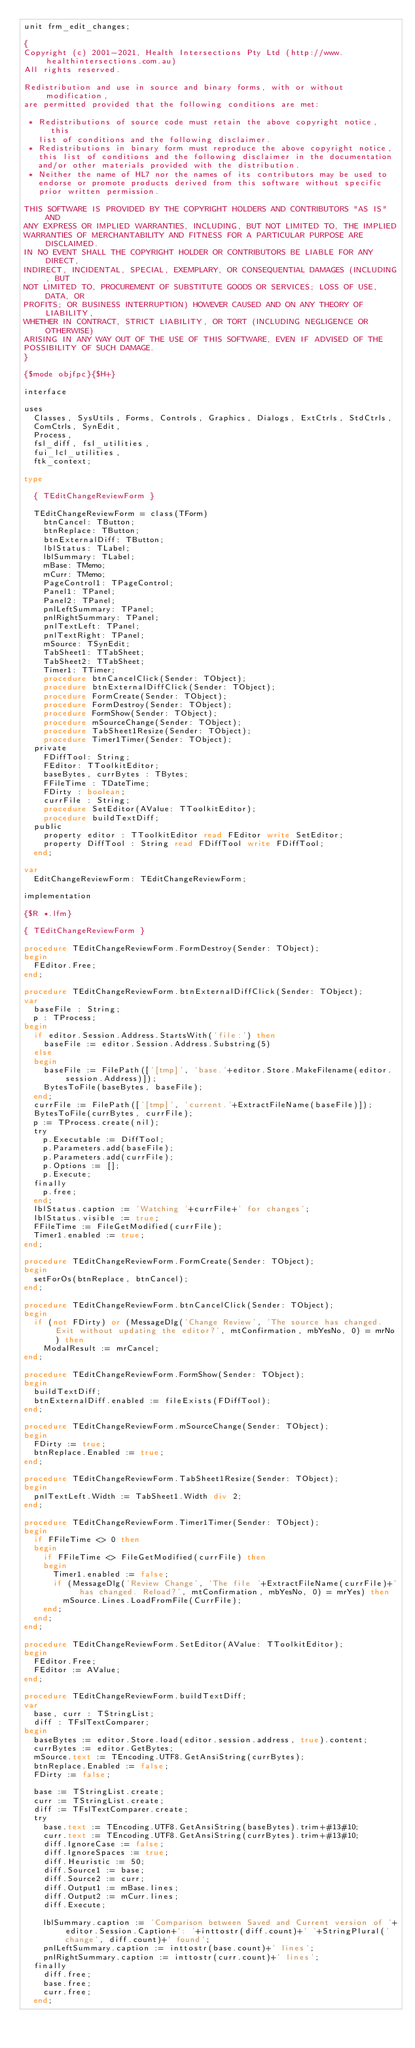Convert code to text. <code><loc_0><loc_0><loc_500><loc_500><_Pascal_>unit frm_edit_changes;

{
Copyright (c) 2001-2021, Health Intersections Pty Ltd (http://www.healthintersections.com.au)
All rights reserved.

Redistribution and use in source and binary forms, with or without modification,
are permitted provided that the following conditions are met:

 * Redistributions of source code must retain the above copyright notice, this
   list of conditions and the following disclaimer.
 * Redistributions in binary form must reproduce the above copyright notice,
   this list of conditions and the following disclaimer in the documentation
   and/or other materials provided with the distribution.
 * Neither the name of HL7 nor the names of its contributors may be used to
   endorse or promote products derived from this software without specific
   prior written permission.

THIS SOFTWARE IS PROVIDED BY THE COPYRIGHT HOLDERS AND CONTRIBUTORS "AS IS" AND
ANY EXPRESS OR IMPLIED WARRANTIES, INCLUDING, BUT NOT LIMITED TO, THE IMPLIED
WARRANTIES OF MERCHANTABILITY AND FITNESS FOR A PARTICULAR PURPOSE ARE DISCLAIMED.
IN NO EVENT SHALL THE COPYRIGHT HOLDER OR CONTRIBUTORS BE LIABLE FOR ANY DIRECT,
INDIRECT, INCIDENTAL, SPECIAL, EXEMPLARY, OR CONSEQUENTIAL DAMAGES (INCLUDING, BUT
NOT LIMITED TO, PROCUREMENT OF SUBSTITUTE GOODS OR SERVICES; LOSS OF USE, DATA, OR
PROFITS; OR BUSINESS INTERRUPTION) HOWEVER CAUSED AND ON ANY THEORY OF LIABILITY,
WHETHER IN CONTRACT, STRICT LIABILITY, OR TORT (INCLUDING NEGLIGENCE OR OTHERWISE)
ARISING IN ANY WAY OUT OF THE USE OF THIS SOFTWARE, EVEN IF ADVISED OF THE
POSSIBILITY OF SUCH DAMAGE.
}

{$mode objfpc}{$H+}

interface

uses
  Classes, SysUtils, Forms, Controls, Graphics, Dialogs, ExtCtrls, StdCtrls,
  ComCtrls, SynEdit,
  Process,
  fsl_diff, fsl_utilities,
  fui_lcl_utilities,
  ftk_context;

type

  { TEditChangeReviewForm }

  TEditChangeReviewForm = class(TForm)
    btnCancel: TButton;
    btnReplace: TButton;
    btnExternalDiff: TButton;
    lblStatus: TLabel;
    lblSummary: TLabel;
    mBase: TMemo;
    mCurr: TMemo;
    PageControl1: TPageControl;
    Panel1: TPanel;
    Panel2: TPanel;
    pnlLeftSummary: TPanel;
    pnlRightSummary: TPanel;
    pnlTextLeft: TPanel;
    pnlTextRight: TPanel;
    mSource: TSynEdit;
    TabSheet1: TTabSheet;
    TabSheet2: TTabSheet;
    Timer1: TTimer;
    procedure btnCancelClick(Sender: TObject);
    procedure btnExternalDiffClick(Sender: TObject);
    procedure FormCreate(Sender: TObject);
    procedure FormDestroy(Sender: TObject);
    procedure FormShow(Sender: TObject);
    procedure mSourceChange(Sender: TObject);
    procedure TabSheet1Resize(Sender: TObject);
    procedure Timer1Timer(Sender: TObject);
  private
    FDiffTool: String;
    FEditor: TToolkitEditor;
    baseBytes, currBytes : TBytes;
    FFileTime : TDateTime;
    FDirty : boolean;
    currFile : String;
    procedure SetEditor(AValue: TToolkitEditor);
    procedure buildTextDiff;
  public
    property editor : TToolkitEditor read FEditor write SetEditor;
    property DiffTool : String read FDiffTool write FDiffTool;
  end;

var
  EditChangeReviewForm: TEditChangeReviewForm;

implementation

{$R *.lfm}

{ TEditChangeReviewForm }

procedure TEditChangeReviewForm.FormDestroy(Sender: TObject);
begin
  FEditor.Free;
end;

procedure TEditChangeReviewForm.btnExternalDiffClick(Sender: TObject);
var
  baseFile : String;
  p : TProcess;
begin
  if editor.Session.Address.StartsWith('file:') then
    baseFile := editor.Session.Address.Substring(5)
  else
  begin
    baseFile := FilePath(['[tmp]', 'base.'+editor.Store.MakeFilename(editor.session.Address)]);
    BytesToFile(baseBytes, baseFile);
  end;
  currFile := FilePath(['[tmp]', 'current.'+ExtractFileName(baseFile)]);
  BytesToFile(currBytes, currFile);
  p := TProcess.create(nil);
  try
    p.Executable := DiffTool;
    p.Parameters.add(baseFile);
    p.Parameters.add(currFile);
    p.Options := [];
    p.Execute;
  finally
    p.free;
  end;
  lblStatus.caption := 'Watching '+currFile+' for changes';
  lblStatus.visible := true;
  FFileTime := FileGetModified(currFile);
  Timer1.enabled := true;
end;

procedure TEditChangeReviewForm.FormCreate(Sender: TObject);
begin
  setForOs(btnReplace, btnCancel);
end;

procedure TEditChangeReviewForm.btnCancelClick(Sender: TObject);
begin
  if (not FDirty) or (MessageDlg('Change Review', 'The source has changed. Exit without updating the editor?', mtConfirmation, mbYesNo, 0) = mrNo) then
    ModalResult := mrCancel;
end;

procedure TEditChangeReviewForm.FormShow(Sender: TObject);
begin
  buildTextDiff;
  btnExternalDiff.enabled := fileExists(FDiffTool);
end;

procedure TEditChangeReviewForm.mSourceChange(Sender: TObject);
begin
  FDirty := true;
  btnReplace.Enabled := true;
end;

procedure TEditChangeReviewForm.TabSheet1Resize(Sender: TObject);
begin
  pnlTextLeft.Width := TabSheet1.Width div 2;
end;

procedure TEditChangeReviewForm.Timer1Timer(Sender: TObject);
begin
  if FFileTime <> 0 then
  begin
    if FFileTime <> FileGetModified(currFile) then
    begin
      Timer1.enabled := false;
      if (MessageDlg('Review Change', 'The file '+ExtractFileName(currFile)+' has changed. Reload?', mtConfirmation, mbYesNo, 0) = mrYes) then
        mSource.Lines.LoadFromFile(CurrFile);
    end;
  end;
end;

procedure TEditChangeReviewForm.SetEditor(AValue: TToolkitEditor);
begin
  FEditor.Free;
  FEditor := AValue;
end;

procedure TEditChangeReviewForm.buildTextDiff;
var
  base, curr : TStringList;
  diff : TFslTextComparer;
begin
  baseBytes := editor.Store.load(editor.session.address, true).content;
  currBytes := editor.GetBytes;
  mSource.text := TEncoding.UTF8.GetAnsiString(currBytes);
  btnReplace.Enabled := false;
  FDirty := false;

  base := TStringList.create;
  curr := TStringList.create;
  diff := TFslTextComparer.create;
  try
    base.text := TEncoding.UTF8.GetAnsiString(baseBytes).trim+#13#10;
    curr.text := TEncoding.UTF8.GetAnsiString(currBytes).trim+#13#10;
    diff.IgnoreCase := false;
    diff.IgnoreSpaces := true;
    diff.Heuristic := 50;
    diff.Source1 := base;
    diff.Source2 := curr;
    diff.Output1 := mBase.lines;
    diff.Output2 := mCurr.lines;
    diff.Execute;

    lblSummary.caption := 'Comparison between Saved and Current version of '+editor.Session.Caption+': '+inttostr(diff.count)+' '+StringPlural('change', diff.count)+' found';
    pnlLeftSummary.caption := inttostr(base.count)+' lines';
    pnlRightSummary.caption := inttostr(curr.count)+' lines';
  finally
    diff.free;
    base.free;
    curr.free;
  end;</code> 